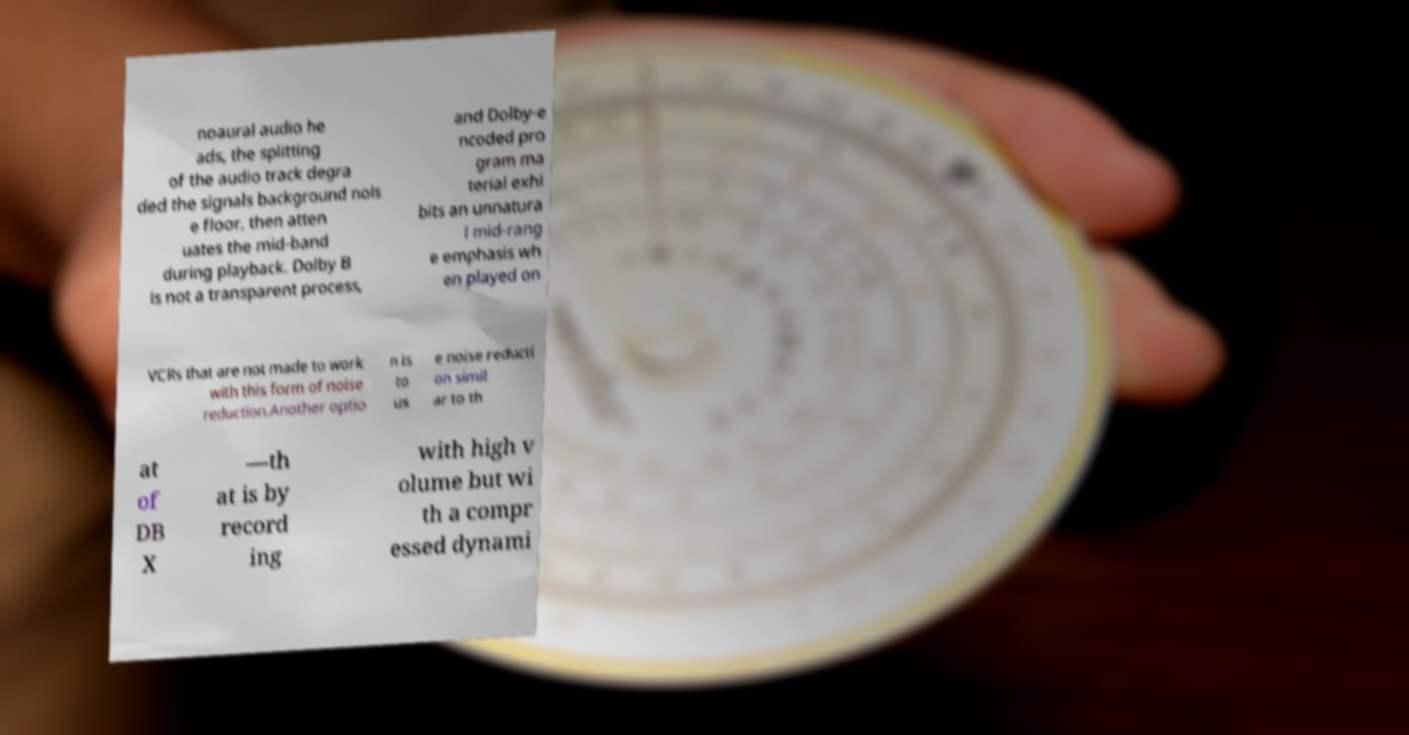Could you assist in decoding the text presented in this image and type it out clearly? noaural audio he ads, the splitting of the audio track degra ded the signals background nois e floor, then atten uates the mid-band during playback. Dolby B is not a transparent process, and Dolby-e ncoded pro gram ma terial exhi bits an unnatura l mid-rang e emphasis wh en played on VCRs that are not made to work with this form of noise reduction.Another optio n is to us e noise reducti on simil ar to th at of DB X —th at is by record ing with high v olume but wi th a compr essed dynami 